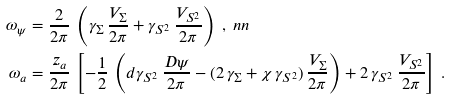<formula> <loc_0><loc_0><loc_500><loc_500>\omega _ { \psi } & = \frac { 2 } { 2 \pi } \, \left ( \gamma _ { \Sigma } \, \frac { V _ { \Sigma } } { 2 \pi } + \gamma _ { S ^ { 2 } } \, \frac { V _ { S ^ { 2 } } } { 2 \pi } \right ) \ , \ n n \\ \omega _ { a } & = \frac { z _ { a } } { 2 \pi } \, \left [ - \frac { 1 } { 2 } \, \left ( d \gamma _ { S ^ { 2 } } \, \frac { D \psi } { 2 \pi } - ( 2 \, \gamma _ { \Sigma } + \chi \, \gamma _ { S ^ { 2 } } ) \, \frac { V _ { \Sigma } } { 2 \pi } \right ) + 2 \, \gamma _ { S ^ { 2 } } \, \frac { V _ { S ^ { 2 } } } { 2 \pi } \right ] \ .</formula> 